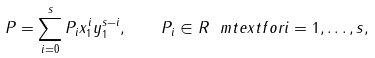<formula> <loc_0><loc_0><loc_500><loc_500>P = \sum _ { i = 0 } ^ { s } P _ { i } x _ { 1 } ^ { i } y _ { 1 } ^ { s - i } , \quad P _ { i } \in R \ m t e x t { f o r } i = 1 , \dots , s ,</formula> 